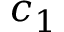Convert formula to latex. <formula><loc_0><loc_0><loc_500><loc_500>c _ { 1 }</formula> 